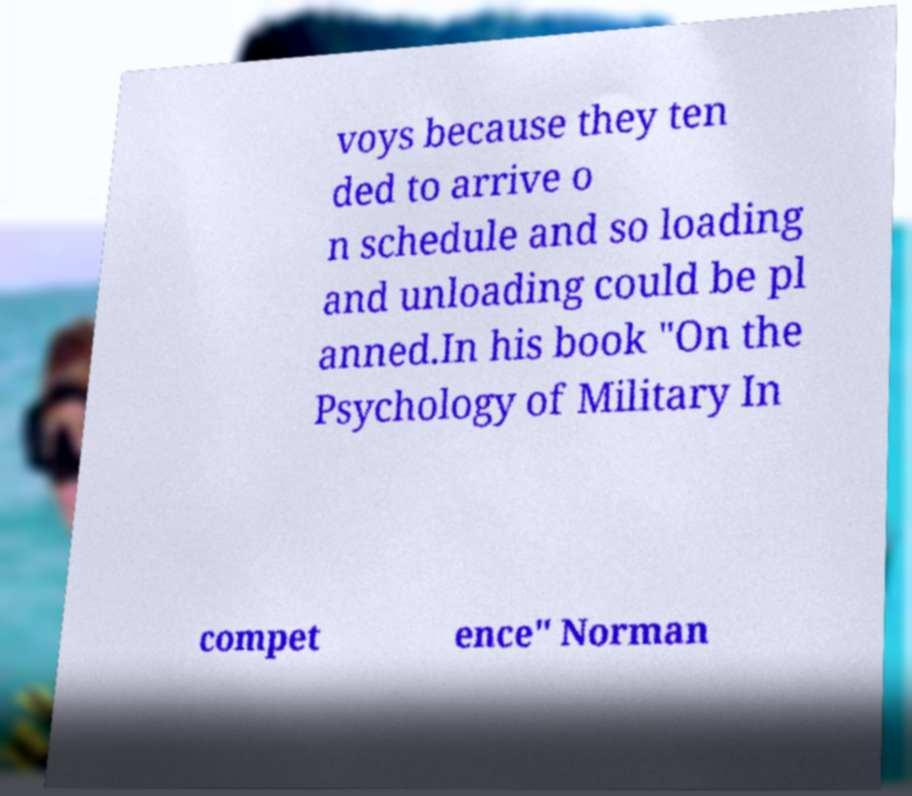Could you assist in decoding the text presented in this image and type it out clearly? voys because they ten ded to arrive o n schedule and so loading and unloading could be pl anned.In his book "On the Psychology of Military In compet ence" Norman 